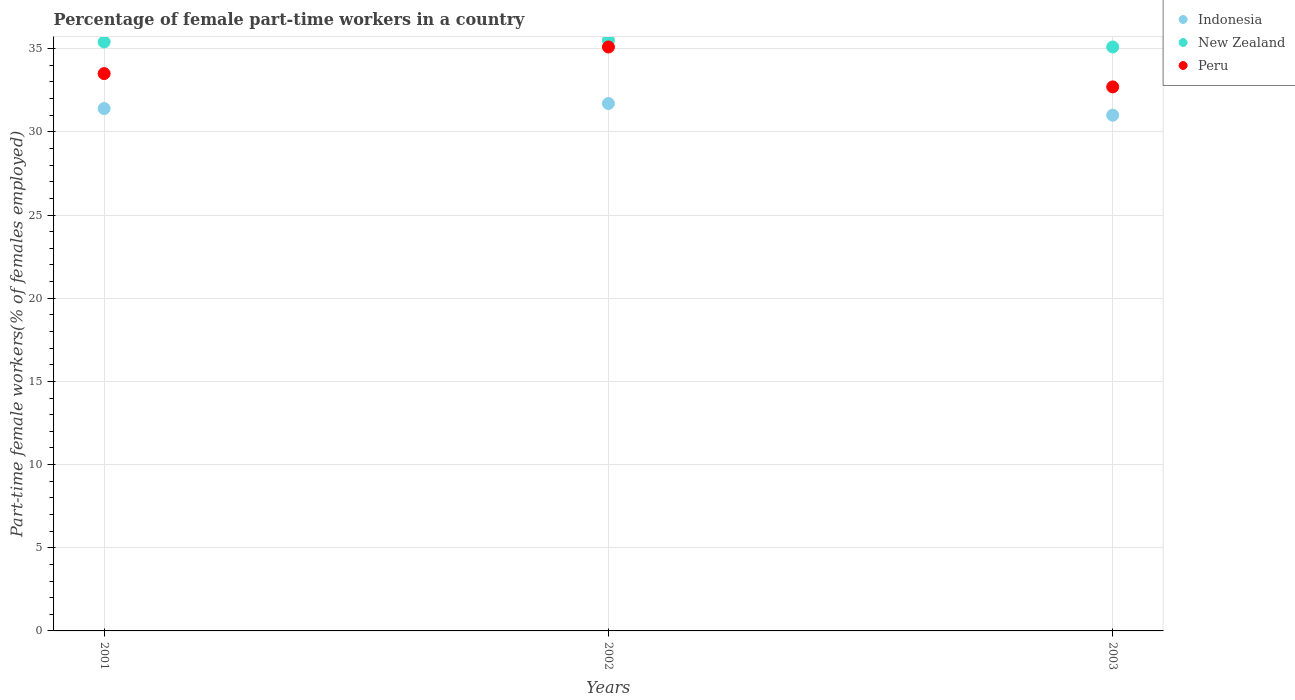How many different coloured dotlines are there?
Keep it short and to the point. 3. Is the number of dotlines equal to the number of legend labels?
Provide a short and direct response. Yes. Across all years, what is the maximum percentage of female part-time workers in Peru?
Make the answer very short. 35.1. In which year was the percentage of female part-time workers in Peru maximum?
Provide a succinct answer. 2002. In which year was the percentage of female part-time workers in New Zealand minimum?
Offer a terse response. 2003. What is the total percentage of female part-time workers in New Zealand in the graph?
Your answer should be compact. 106. What is the difference between the percentage of female part-time workers in New Zealand in 2002 and that in 2003?
Your answer should be compact. 0.4. What is the difference between the percentage of female part-time workers in New Zealand in 2003 and the percentage of female part-time workers in Peru in 2001?
Provide a succinct answer. 1.6. What is the average percentage of female part-time workers in Peru per year?
Keep it short and to the point. 33.77. In the year 2001, what is the difference between the percentage of female part-time workers in Indonesia and percentage of female part-time workers in New Zealand?
Offer a terse response. -4. What is the ratio of the percentage of female part-time workers in Indonesia in 2002 to that in 2003?
Offer a very short reply. 1.02. Is the difference between the percentage of female part-time workers in Indonesia in 2002 and 2003 greater than the difference between the percentage of female part-time workers in New Zealand in 2002 and 2003?
Make the answer very short. Yes. What is the difference between the highest and the second highest percentage of female part-time workers in New Zealand?
Ensure brevity in your answer.  0.1. What is the difference between the highest and the lowest percentage of female part-time workers in Indonesia?
Offer a very short reply. 0.7. Does the percentage of female part-time workers in Peru monotonically increase over the years?
Provide a short and direct response. No. Is the percentage of female part-time workers in Peru strictly less than the percentage of female part-time workers in Indonesia over the years?
Give a very brief answer. No. How many dotlines are there?
Give a very brief answer. 3. How many years are there in the graph?
Provide a succinct answer. 3. Does the graph contain any zero values?
Provide a succinct answer. No. Does the graph contain grids?
Offer a terse response. Yes. What is the title of the graph?
Keep it short and to the point. Percentage of female part-time workers in a country. What is the label or title of the Y-axis?
Your response must be concise. Part-time female workers(% of females employed). What is the Part-time female workers(% of females employed) of Indonesia in 2001?
Give a very brief answer. 31.4. What is the Part-time female workers(% of females employed) of New Zealand in 2001?
Offer a very short reply. 35.4. What is the Part-time female workers(% of females employed) of Peru in 2001?
Ensure brevity in your answer.  33.5. What is the Part-time female workers(% of females employed) in Indonesia in 2002?
Ensure brevity in your answer.  31.7. What is the Part-time female workers(% of females employed) of New Zealand in 2002?
Provide a succinct answer. 35.5. What is the Part-time female workers(% of females employed) of Peru in 2002?
Provide a succinct answer. 35.1. What is the Part-time female workers(% of females employed) of Indonesia in 2003?
Your answer should be compact. 31. What is the Part-time female workers(% of females employed) in New Zealand in 2003?
Provide a short and direct response. 35.1. What is the Part-time female workers(% of females employed) of Peru in 2003?
Provide a succinct answer. 32.7. Across all years, what is the maximum Part-time female workers(% of females employed) of Indonesia?
Give a very brief answer. 31.7. Across all years, what is the maximum Part-time female workers(% of females employed) of New Zealand?
Keep it short and to the point. 35.5. Across all years, what is the maximum Part-time female workers(% of females employed) in Peru?
Provide a short and direct response. 35.1. Across all years, what is the minimum Part-time female workers(% of females employed) of Indonesia?
Your response must be concise. 31. Across all years, what is the minimum Part-time female workers(% of females employed) of New Zealand?
Offer a terse response. 35.1. Across all years, what is the minimum Part-time female workers(% of females employed) in Peru?
Offer a terse response. 32.7. What is the total Part-time female workers(% of females employed) of Indonesia in the graph?
Provide a short and direct response. 94.1. What is the total Part-time female workers(% of females employed) in New Zealand in the graph?
Ensure brevity in your answer.  106. What is the total Part-time female workers(% of females employed) of Peru in the graph?
Your answer should be very brief. 101.3. What is the difference between the Part-time female workers(% of females employed) in New Zealand in 2001 and that in 2003?
Your answer should be very brief. 0.3. What is the difference between the Part-time female workers(% of females employed) of Peru in 2001 and that in 2003?
Make the answer very short. 0.8. What is the difference between the Part-time female workers(% of females employed) of Indonesia in 2002 and that in 2003?
Offer a very short reply. 0.7. What is the difference between the Part-time female workers(% of females employed) in Indonesia in 2001 and the Part-time female workers(% of females employed) in New Zealand in 2002?
Ensure brevity in your answer.  -4.1. What is the difference between the Part-time female workers(% of females employed) in New Zealand in 2001 and the Part-time female workers(% of females employed) in Peru in 2002?
Keep it short and to the point. 0.3. What is the difference between the Part-time female workers(% of females employed) in New Zealand in 2001 and the Part-time female workers(% of females employed) in Peru in 2003?
Keep it short and to the point. 2.7. What is the difference between the Part-time female workers(% of females employed) in New Zealand in 2002 and the Part-time female workers(% of females employed) in Peru in 2003?
Provide a succinct answer. 2.8. What is the average Part-time female workers(% of females employed) of Indonesia per year?
Your response must be concise. 31.37. What is the average Part-time female workers(% of females employed) in New Zealand per year?
Provide a succinct answer. 35.33. What is the average Part-time female workers(% of females employed) of Peru per year?
Your answer should be very brief. 33.77. In the year 2001, what is the difference between the Part-time female workers(% of females employed) of Indonesia and Part-time female workers(% of females employed) of New Zealand?
Provide a short and direct response. -4. In the year 2001, what is the difference between the Part-time female workers(% of females employed) of New Zealand and Part-time female workers(% of females employed) of Peru?
Offer a terse response. 1.9. In the year 2002, what is the difference between the Part-time female workers(% of females employed) of Indonesia and Part-time female workers(% of females employed) of New Zealand?
Give a very brief answer. -3.8. In the year 2003, what is the difference between the Part-time female workers(% of females employed) in Indonesia and Part-time female workers(% of females employed) in Peru?
Keep it short and to the point. -1.7. In the year 2003, what is the difference between the Part-time female workers(% of females employed) in New Zealand and Part-time female workers(% of females employed) in Peru?
Your answer should be compact. 2.4. What is the ratio of the Part-time female workers(% of females employed) in Indonesia in 2001 to that in 2002?
Ensure brevity in your answer.  0.99. What is the ratio of the Part-time female workers(% of females employed) of Peru in 2001 to that in 2002?
Give a very brief answer. 0.95. What is the ratio of the Part-time female workers(% of females employed) of Indonesia in 2001 to that in 2003?
Ensure brevity in your answer.  1.01. What is the ratio of the Part-time female workers(% of females employed) of New Zealand in 2001 to that in 2003?
Your response must be concise. 1.01. What is the ratio of the Part-time female workers(% of females employed) in Peru in 2001 to that in 2003?
Give a very brief answer. 1.02. What is the ratio of the Part-time female workers(% of females employed) in Indonesia in 2002 to that in 2003?
Your response must be concise. 1.02. What is the ratio of the Part-time female workers(% of females employed) in New Zealand in 2002 to that in 2003?
Keep it short and to the point. 1.01. What is the ratio of the Part-time female workers(% of females employed) of Peru in 2002 to that in 2003?
Your answer should be compact. 1.07. What is the difference between the highest and the second highest Part-time female workers(% of females employed) in New Zealand?
Offer a very short reply. 0.1. What is the difference between the highest and the second highest Part-time female workers(% of females employed) of Peru?
Offer a terse response. 1.6. What is the difference between the highest and the lowest Part-time female workers(% of females employed) of Indonesia?
Provide a short and direct response. 0.7. 